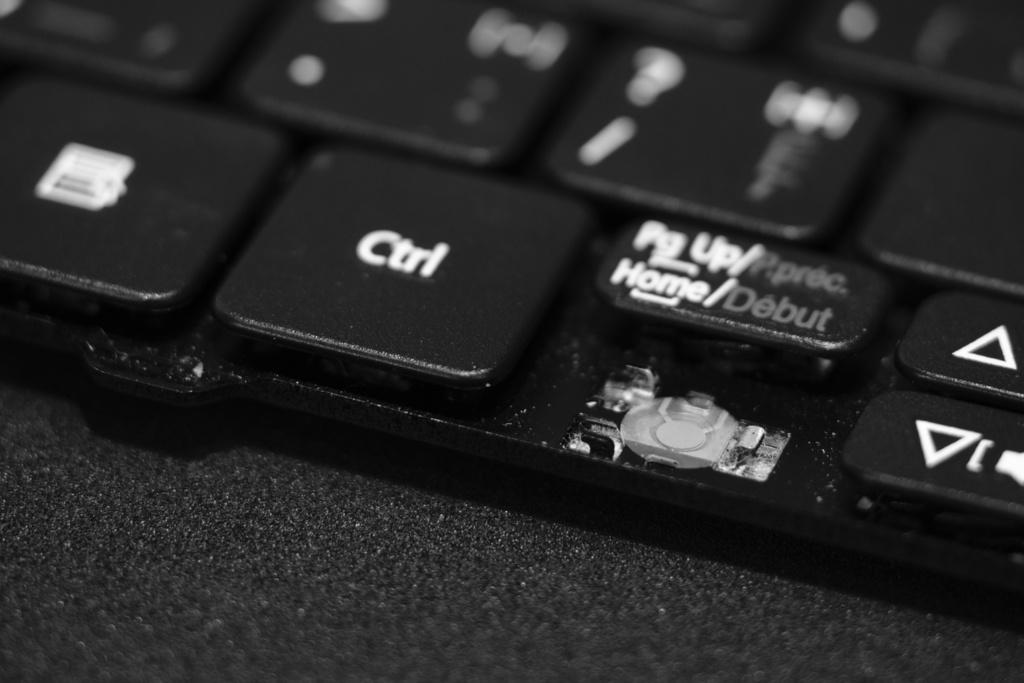<image>
Present a compact description of the photo's key features. One of the button to go left is missing on the keyboard. 